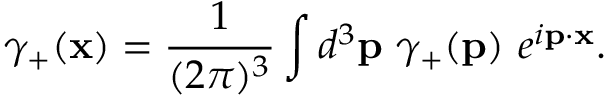Convert formula to latex. <formula><loc_0><loc_0><loc_500><loc_500>\gamma _ { + } ( { x } ) = \frac { 1 } { ( 2 \pi ) ^ { 3 } } \int d ^ { 3 } { p } \gamma _ { + } ( { p } ) e ^ { i { p } \cdot { x } } .</formula> 